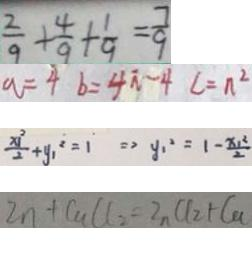Convert formula to latex. <formula><loc_0><loc_0><loc_500><loc_500>\frac { 2 } { 9 } + \frac { 4 } { 9 } + \frac { 1 } { 9 } = \frac { 7 } { 9 } 
 a = 4 b = 4 \pi - 4 c = \pi ^ { 2 } 
 \frac { x ^ { 2 } } { 2 } + y _ { 1 } ^ { 2 } = 1 \Rightarrow y _ { 1 } ^ { 2 } = 1 - \frac { x _ { 1 } ^ { 2 } } { 2 } 
 Z n + C a C l _ { 2 } = Z n C l _ { 2 } + C a</formula> 